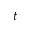Convert formula to latex. <formula><loc_0><loc_0><loc_500><loc_500>t</formula> 